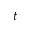Convert formula to latex. <formula><loc_0><loc_0><loc_500><loc_500>t</formula> 